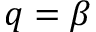Convert formula to latex. <formula><loc_0><loc_0><loc_500><loc_500>q = \beta</formula> 